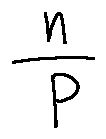<formula> <loc_0><loc_0><loc_500><loc_500>\frac { n } { P }</formula> 